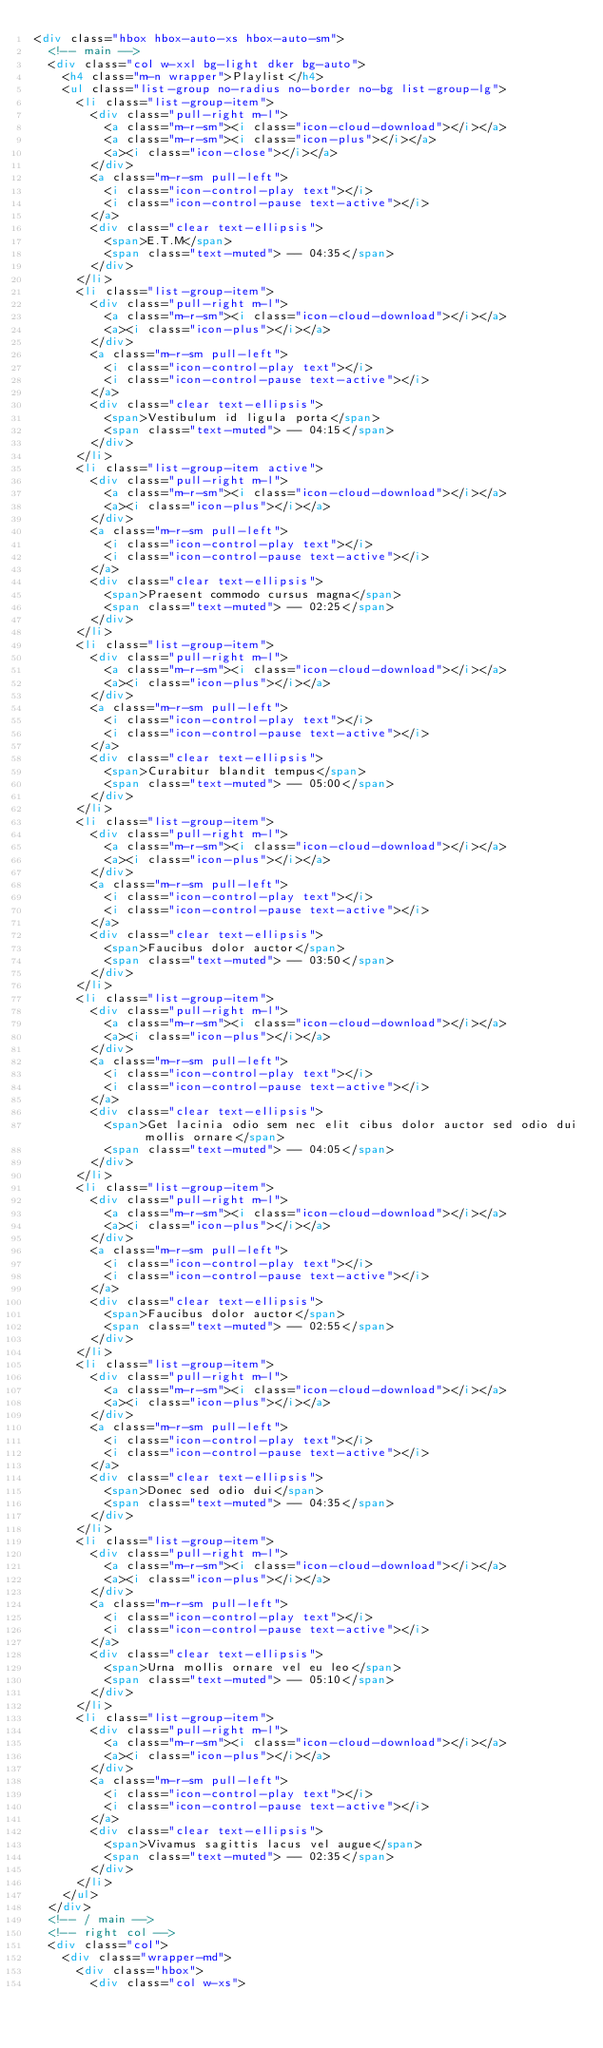Convert code to text. <code><loc_0><loc_0><loc_500><loc_500><_HTML_><div class="hbox hbox-auto-xs hbox-auto-sm">
  <!-- main -->
  <div class="col w-xxl bg-light dker bg-auto">
    <h4 class="m-n wrapper">Playlist</h4>
    <ul class="list-group no-radius no-border no-bg list-group-lg">
      <li class="list-group-item">
        <div class="pull-right m-l">
          <a class="m-r-sm"><i class="icon-cloud-download"></i></a>
          <a class="m-r-sm"><i class="icon-plus"></i></a>
          <a><i class="icon-close"></i></a>
        </div>
        <a class="m-r-sm pull-left">
          <i class="icon-control-play text"></i>
          <i class="icon-control-pause text-active"></i>
        </a>
        <div class="clear text-ellipsis">
          <span>E.T.M</span>
          <span class="text-muted"> -- 04:35</span>
        </div>
      </li>
      <li class="list-group-item">
        <div class="pull-right m-l">
          <a class="m-r-sm"><i class="icon-cloud-download"></i></a>
          <a><i class="icon-plus"></i></a>
        </div>
        <a class="m-r-sm pull-left">
          <i class="icon-control-play text"></i>
          <i class="icon-control-pause text-active"></i>
        </a>
        <div class="clear text-ellipsis">
          <span>Vestibulum id ligula porta</span>
          <span class="text-muted"> -- 04:15</span>
        </div>
      </li>
      <li class="list-group-item active">
        <div class="pull-right m-l">
          <a class="m-r-sm"><i class="icon-cloud-download"></i></a>
          <a><i class="icon-plus"></i></a>
        </div>
        <a class="m-r-sm pull-left">
          <i class="icon-control-play text"></i>
          <i class="icon-control-pause text-active"></i>
        </a>
        <div class="clear text-ellipsis">
          <span>Praesent commodo cursus magna</span>
          <span class="text-muted"> -- 02:25</span>
        </div>
      </li>
      <li class="list-group-item">
        <div class="pull-right m-l">
          <a class="m-r-sm"><i class="icon-cloud-download"></i></a>
          <a><i class="icon-plus"></i></a>
        </div>
        <a class="m-r-sm pull-left">
          <i class="icon-control-play text"></i>
          <i class="icon-control-pause text-active"></i>
        </a>
        <div class="clear text-ellipsis">
          <span>Curabitur blandit tempus</span>
          <span class="text-muted"> -- 05:00</span>
        </div>
      </li>
      <li class="list-group-item">
        <div class="pull-right m-l">
          <a class="m-r-sm"><i class="icon-cloud-download"></i></a>
          <a><i class="icon-plus"></i></a>
        </div>
        <a class="m-r-sm pull-left">
          <i class="icon-control-play text"></i>
          <i class="icon-control-pause text-active"></i>
        </a>
        <div class="clear text-ellipsis">
          <span>Faucibus dolor auctor</span>
          <span class="text-muted"> -- 03:50</span>
        </div>
      </li>
      <li class="list-group-item">
        <div class="pull-right m-l">
          <a class="m-r-sm"><i class="icon-cloud-download"></i></a>
          <a><i class="icon-plus"></i></a>
        </div>
        <a class="m-r-sm pull-left">
          <i class="icon-control-play text"></i>
          <i class="icon-control-pause text-active"></i>
        </a>
        <div class="clear text-ellipsis">
          <span>Get lacinia odio sem nec elit cibus dolor auctor sed odio dui mollis ornare</span>
          <span class="text-muted"> -- 04:05</span>
        </div>
      </li>
      <li class="list-group-item">
        <div class="pull-right m-l">
          <a class="m-r-sm"><i class="icon-cloud-download"></i></a>
          <a><i class="icon-plus"></i></a>
        </div>
        <a class="m-r-sm pull-left">
          <i class="icon-control-play text"></i>
          <i class="icon-control-pause text-active"></i>
        </a>
        <div class="clear text-ellipsis">
          <span>Faucibus dolor auctor</span>
          <span class="text-muted"> -- 02:55</span>
        </div>
      </li>
      <li class="list-group-item">
        <div class="pull-right m-l">
          <a class="m-r-sm"><i class="icon-cloud-download"></i></a>
          <a><i class="icon-plus"></i></a>
        </div>
        <a class="m-r-sm pull-left">
          <i class="icon-control-play text"></i>
          <i class="icon-control-pause text-active"></i>
        </a>
        <div class="clear text-ellipsis">
          <span>Donec sed odio dui</span>
          <span class="text-muted"> -- 04:35</span>
        </div>
      </li>
      <li class="list-group-item">
        <div class="pull-right m-l">
          <a class="m-r-sm"><i class="icon-cloud-download"></i></a>
          <a><i class="icon-plus"></i></a>
        </div>
        <a class="m-r-sm pull-left">
          <i class="icon-control-play text"></i>
          <i class="icon-control-pause text-active"></i>
        </a>
        <div class="clear text-ellipsis">
          <span>Urna mollis ornare vel eu leo</span>
          <span class="text-muted"> -- 05:10</span>
        </div>
      </li>
      <li class="list-group-item">
        <div class="pull-right m-l">
          <a class="m-r-sm"><i class="icon-cloud-download"></i></a>
          <a><i class="icon-plus"></i></a>
        </div>
        <a class="m-r-sm pull-left">
          <i class="icon-control-play text"></i>
          <i class="icon-control-pause text-active"></i>
        </a>
        <div class="clear text-ellipsis">
          <span>Vivamus sagittis lacus vel augue</span>
          <span class="text-muted"> -- 02:35</span>
        </div>
      </li>
    </ul>
  </div>
  <!-- / main -->
  <!-- right col -->
  <div class="col">    
    <div class="wrapper-md">
      <div class="hbox">
        <div class="col w-xs"></code> 